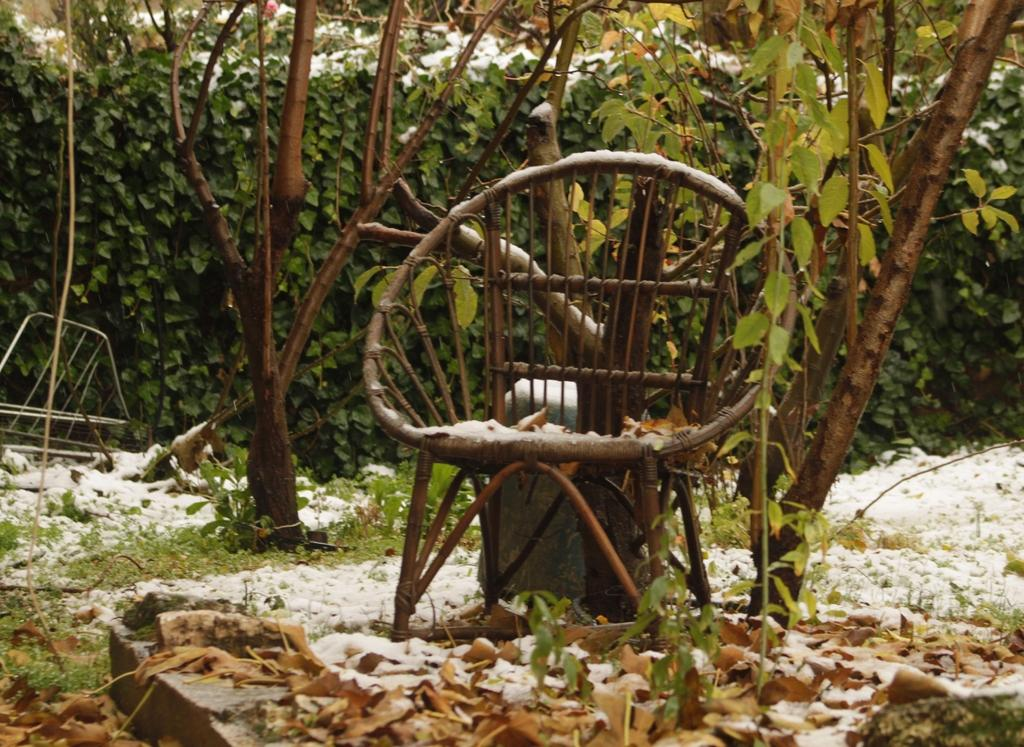What type of furniture is present in the image? There is a chair in the image. What is the weather or season suggested by the image? The presence of snow in the image suggests a winter season. What type of vegetation can be seen in the image? There are leaves and plants visible in the image. What is the material of the object in the background? There is a metal object in the background of the image. What type of canvas is being used for the painting in the image? There is no painting or canvas present in the image. What action is the person taking in the image? There is no person or action visible in the image. 